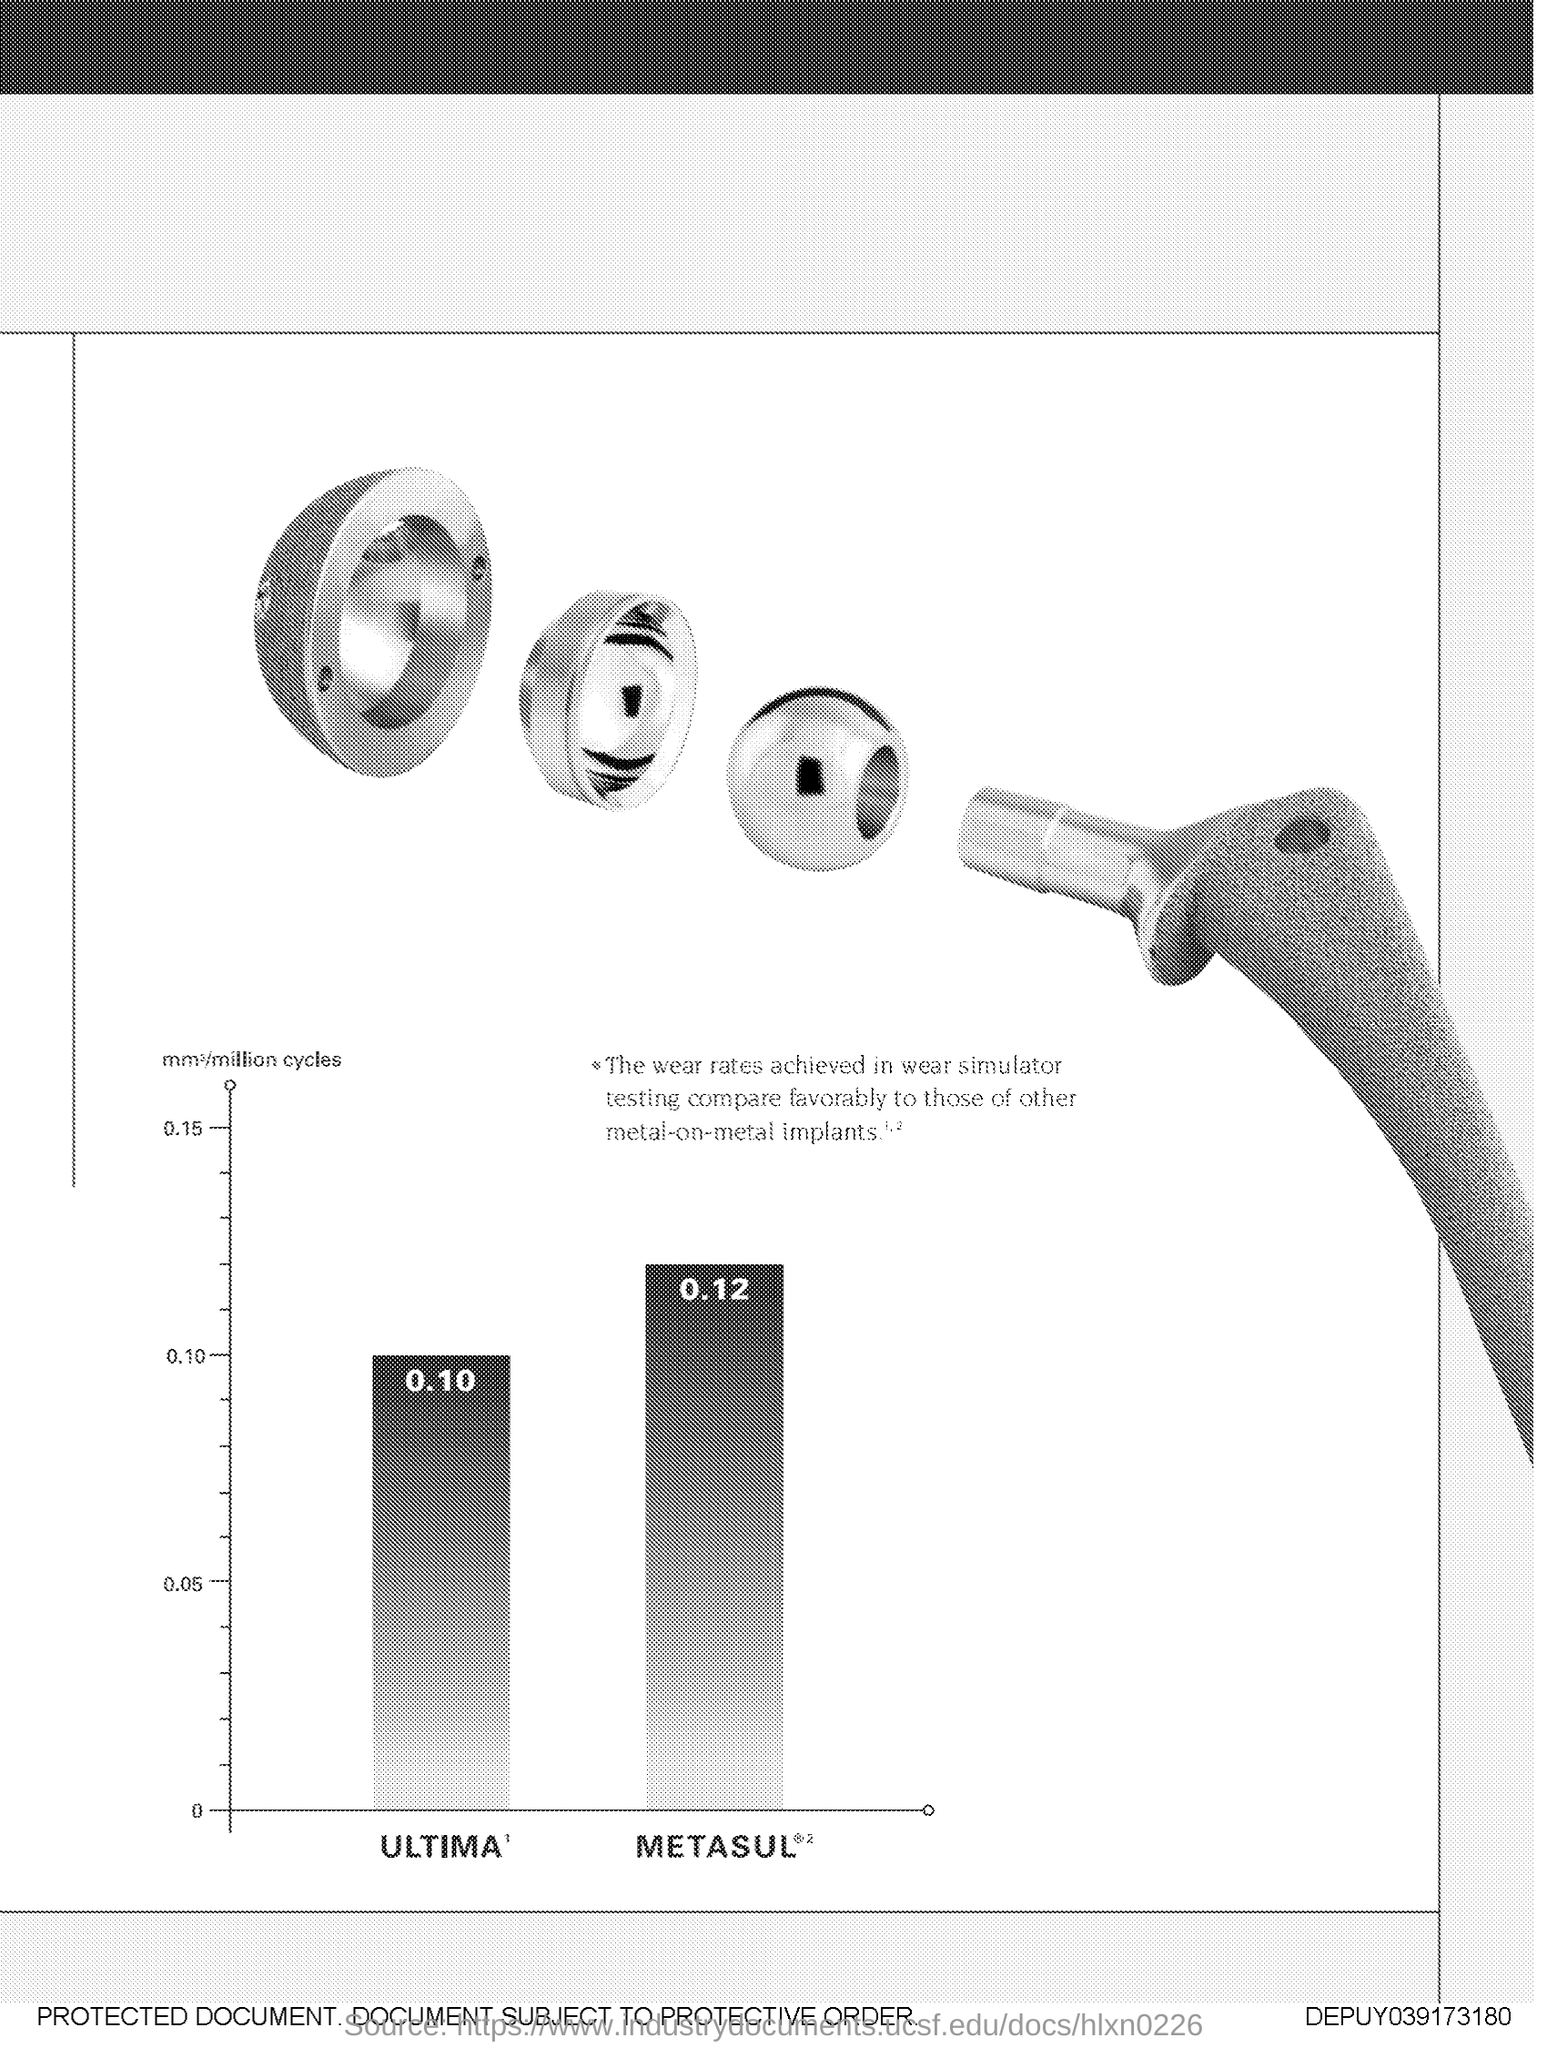What is the highest value plotted in y-axis?
Make the answer very short. 0.15. 